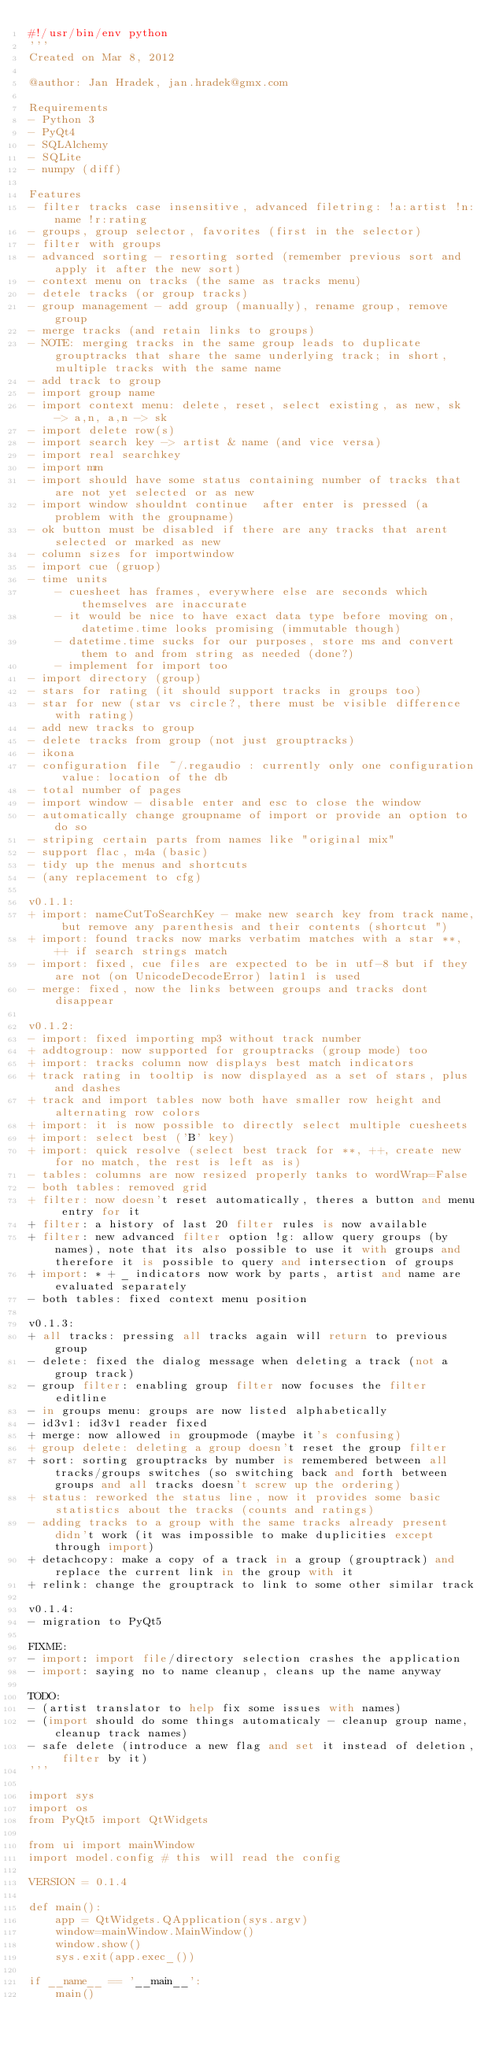Convert code to text. <code><loc_0><loc_0><loc_500><loc_500><_Python_>#!/usr/bin/env python
'''
Created on Mar 8, 2012

@author: Jan Hradek, jan.hradek@gmx.com

Requirements
- Python 3
- PyQt4
- SQLAlchemy
- SQLite
- numpy (diff)

Features
- filter tracks case insensitive, advanced filetring: !a:artist !n:name !r:rating
- groups, group selector, favorites (first in the selector)
- filter with groups
- advanced sorting - resorting sorted (remember previous sort and apply it after the new sort)
- context menu on tracks (the same as tracks menu)
- detele tracks (or group tracks)
- group management - add group (manually), rename group, remove group
- merge tracks (and retain links to groups)
- NOTE: merging tracks in the same group leads to duplicate grouptracks that share the same underlying track; in short, multiple tracks with the same name
- add track to group
- import group name
- import context menu: delete, reset, select existing, as new, sk -> a,n, a,n -> sk
- import delete row(s)
- import search key -> artist & name (and vice versa)
- import real searchkey
- import mm
- import should have some status containing number of tracks that are not yet selected or as new
- import window shouldnt continue  after enter is pressed (a problem with the groupname)
- ok button must be disabled if there are any tracks that arent selected or marked as new
- column sizes for importwindow
- import cue (gruop)
- time units
    - cuesheet has frames, everywhere else are seconds which themselves are inaccurate
    - it would be nice to have exact data type before moving on, datetime.time looks promising (immutable though)
    - datetime.time sucks for our purposes, store ms and convert them to and from string as needed (done?)
    - implement for import too
- import directory (group)
- stars for rating (it should support tracks in groups too)
- star for new (star vs circle?, there must be visible difference with rating)
- add new tracks to group
- delete tracks from group (not just grouptracks)
- ikona
- configuration file ~/.regaudio : currently only one configuration value: location of the db
- total number of pages
- import window - disable enter and esc to close the window
- automatically change groupname of import or provide an option to do so
- striping certain parts from names like "original mix"
- support flac, m4a (basic)
- tidy up the menus and shortcuts
- (any replacement to cfg)

v0.1.1:
+ import: nameCutToSearchKey - make new search key from track name, but remove any parenthesis and their contents (shortcut ")
+ import: found tracks now marks verbatim matches with a star **, ++ if search strings match
- import: fixed, cue files are expected to be in utf-8 but if they are not (on UnicodeDecodeError) latin1 is used
- merge: fixed, now the links between groups and tracks dont disappear

v0.1.2:
- import: fixed importing mp3 without track number
+ addtogroup: now supported for grouptracks (group mode) too
+ import: tracks column now displays best match indicators
+ track rating in tooltip is now displayed as a set of stars, plus and dashes
+ track and import tables now both have smaller row height and alternating row colors
+ import: it is now possible to directly select multiple cuesheets
+ import: select best ('B' key)
+ import: quick resolve (select best track for **, ++, create new for no match, the rest is left as is)
- tables: columns are now resized properly tanks to wordWrap=False
- both tables: removed grid
+ filter: now doesn't reset automatically, theres a button and menu entry for it
+ filter: a history of last 20 filter rules is now available
+ filter: new advanced filter option !g: allow query groups (by names), note that its also possible to use it with groups and therefore it is possible to query and intersection of groups
+ import: * + _ indicators now work by parts, artist and name are evaluated separately
- both tables: fixed context menu position

v0.1.3:
+ all tracks: pressing all tracks again will return to previous group
- delete: fixed the dialog message when deleting a track (not a group track)
- group filter: enabling group filter now focuses the filter editline
- in groups menu: groups are now listed alphabetically
- id3v1: id3v1 reader fixed
+ merge: now allowed in groupmode (maybe it's confusing)
+ group delete: deleting a group doesn't reset the group filter
+ sort: sorting grouptracks by number is remembered between all tracks/groups switches (so switching back and forth between groups and all tracks doesn't screw up the ordering)
+ status: reworked the status line, now it provides some basic statistics about the tracks (counts and ratings)
- adding tracks to a group with the same tracks already present didn't work (it was impossible to make duplicities except through import)
+ detachcopy: make a copy of a track in a group (grouptrack) and replace the current link in the group with it
+ relink: change the grouptrack to link to some other similar track

v0.1.4:
- migration to PyQt5

FIXME:
- import: import file/directory selection crashes the application
- import: saying no to name cleanup, cleans up the name anyway

TODO:
- (artist translator to help fix some issues with names)
- (import should do some things automaticaly - cleanup group name, cleanup track names)
- safe delete (introduce a new flag and set it instead of deletion, filter by it)
'''

import sys
import os
from PyQt5 import QtWidgets

from ui import mainWindow
import model.config # this will read the config

VERSION = 0.1.4

def main():
    app = QtWidgets.QApplication(sys.argv)
    window=mainWindow.MainWindow()
    window.show()
    sys.exit(app.exec_())

if __name__ == '__main__':
    main()
</code> 